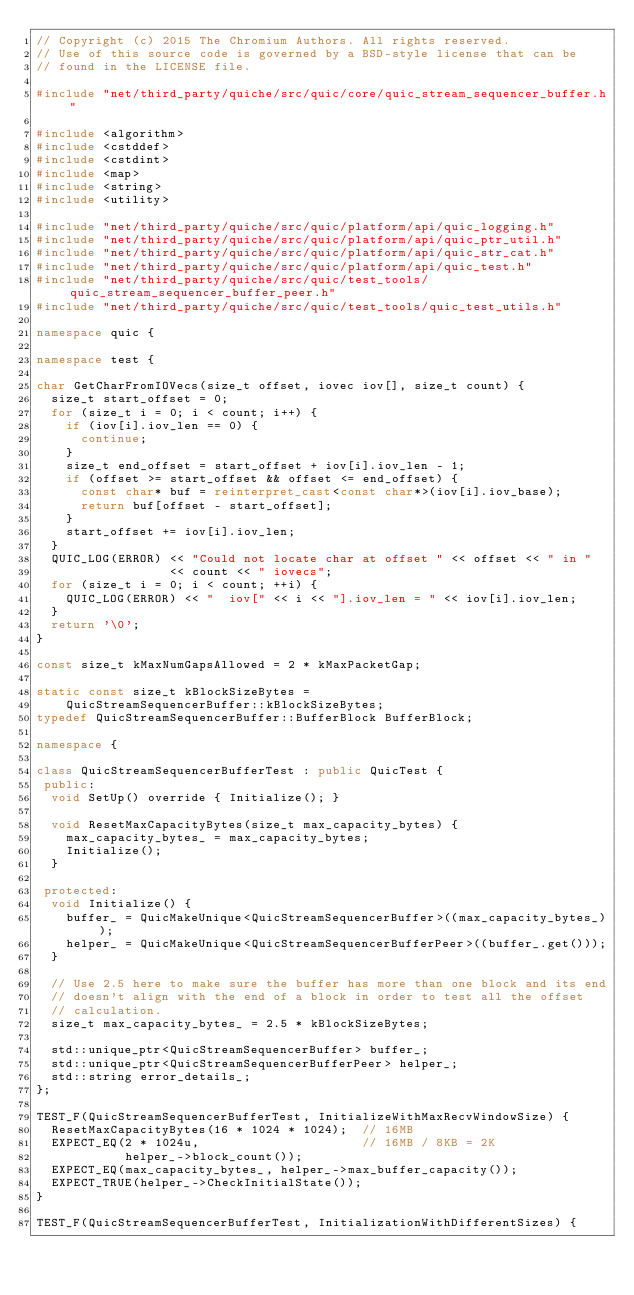<code> <loc_0><loc_0><loc_500><loc_500><_C++_>// Copyright (c) 2015 The Chromium Authors. All rights reserved.
// Use of this source code is governed by a BSD-style license that can be
// found in the LICENSE file.

#include "net/third_party/quiche/src/quic/core/quic_stream_sequencer_buffer.h"

#include <algorithm>
#include <cstddef>
#include <cstdint>
#include <map>
#include <string>
#include <utility>

#include "net/third_party/quiche/src/quic/platform/api/quic_logging.h"
#include "net/third_party/quiche/src/quic/platform/api/quic_ptr_util.h"
#include "net/third_party/quiche/src/quic/platform/api/quic_str_cat.h"
#include "net/third_party/quiche/src/quic/platform/api/quic_test.h"
#include "net/third_party/quiche/src/quic/test_tools/quic_stream_sequencer_buffer_peer.h"
#include "net/third_party/quiche/src/quic/test_tools/quic_test_utils.h"

namespace quic {

namespace test {

char GetCharFromIOVecs(size_t offset, iovec iov[], size_t count) {
  size_t start_offset = 0;
  for (size_t i = 0; i < count; i++) {
    if (iov[i].iov_len == 0) {
      continue;
    }
    size_t end_offset = start_offset + iov[i].iov_len - 1;
    if (offset >= start_offset && offset <= end_offset) {
      const char* buf = reinterpret_cast<const char*>(iov[i].iov_base);
      return buf[offset - start_offset];
    }
    start_offset += iov[i].iov_len;
  }
  QUIC_LOG(ERROR) << "Could not locate char at offset " << offset << " in "
                  << count << " iovecs";
  for (size_t i = 0; i < count; ++i) {
    QUIC_LOG(ERROR) << "  iov[" << i << "].iov_len = " << iov[i].iov_len;
  }
  return '\0';
}

const size_t kMaxNumGapsAllowed = 2 * kMaxPacketGap;

static const size_t kBlockSizeBytes =
    QuicStreamSequencerBuffer::kBlockSizeBytes;
typedef QuicStreamSequencerBuffer::BufferBlock BufferBlock;

namespace {

class QuicStreamSequencerBufferTest : public QuicTest {
 public:
  void SetUp() override { Initialize(); }

  void ResetMaxCapacityBytes(size_t max_capacity_bytes) {
    max_capacity_bytes_ = max_capacity_bytes;
    Initialize();
  }

 protected:
  void Initialize() {
    buffer_ = QuicMakeUnique<QuicStreamSequencerBuffer>((max_capacity_bytes_));
    helper_ = QuicMakeUnique<QuicStreamSequencerBufferPeer>((buffer_.get()));
  }

  // Use 2.5 here to make sure the buffer has more than one block and its end
  // doesn't align with the end of a block in order to test all the offset
  // calculation.
  size_t max_capacity_bytes_ = 2.5 * kBlockSizeBytes;

  std::unique_ptr<QuicStreamSequencerBuffer> buffer_;
  std::unique_ptr<QuicStreamSequencerBufferPeer> helper_;
  std::string error_details_;
};

TEST_F(QuicStreamSequencerBufferTest, InitializeWithMaxRecvWindowSize) {
  ResetMaxCapacityBytes(16 * 1024 * 1024);  // 16MB
  EXPECT_EQ(2 * 1024u,                      // 16MB / 8KB = 2K
            helper_->block_count());
  EXPECT_EQ(max_capacity_bytes_, helper_->max_buffer_capacity());
  EXPECT_TRUE(helper_->CheckInitialState());
}

TEST_F(QuicStreamSequencerBufferTest, InitializationWithDifferentSizes) {</code> 